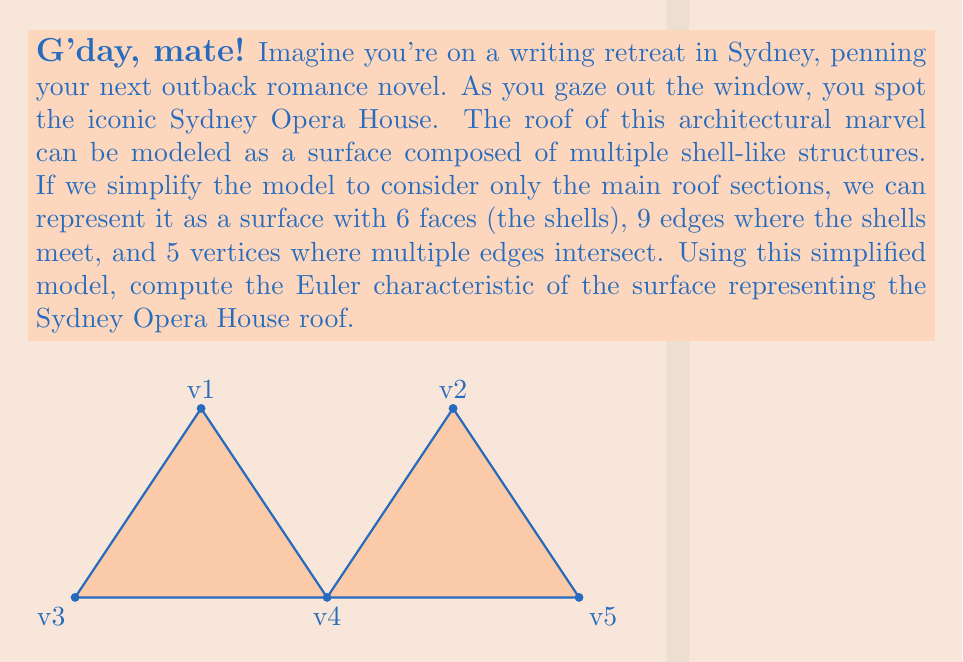Provide a solution to this math problem. Let's approach this step-by-step, using the Euler characteristic formula:

1) The Euler characteristic $\chi$ is defined as:

   $$\chi = V - E + F$$

   Where:
   $V$ = number of vertices
   $E$ = number of edges
   $F$ = number of faces

2) From the information given:
   $V = 5$ (vertices)
   $E = 9$ (edges)
   $F = 6$ (faces or shells)

3) Now, let's substitute these values into the formula:

   $$\chi = 5 - 9 + 6$$

4) Simplifying:
   $$\chi = 5 - 9 + 6 = -4 + 6 = 2$$

5) Therefore, the Euler characteristic of the simplified Sydney Opera House roof model is 2.

This result is consistent with the Euler characteristic of a sphere, which makes sense as the Opera House roof can be thought of as a deformed sphere-like surface. In topology, any surface that can be continuously deformed into a sphere (without cutting or gluing) will have an Euler characteristic of 2.
Answer: $\chi = 2$ 